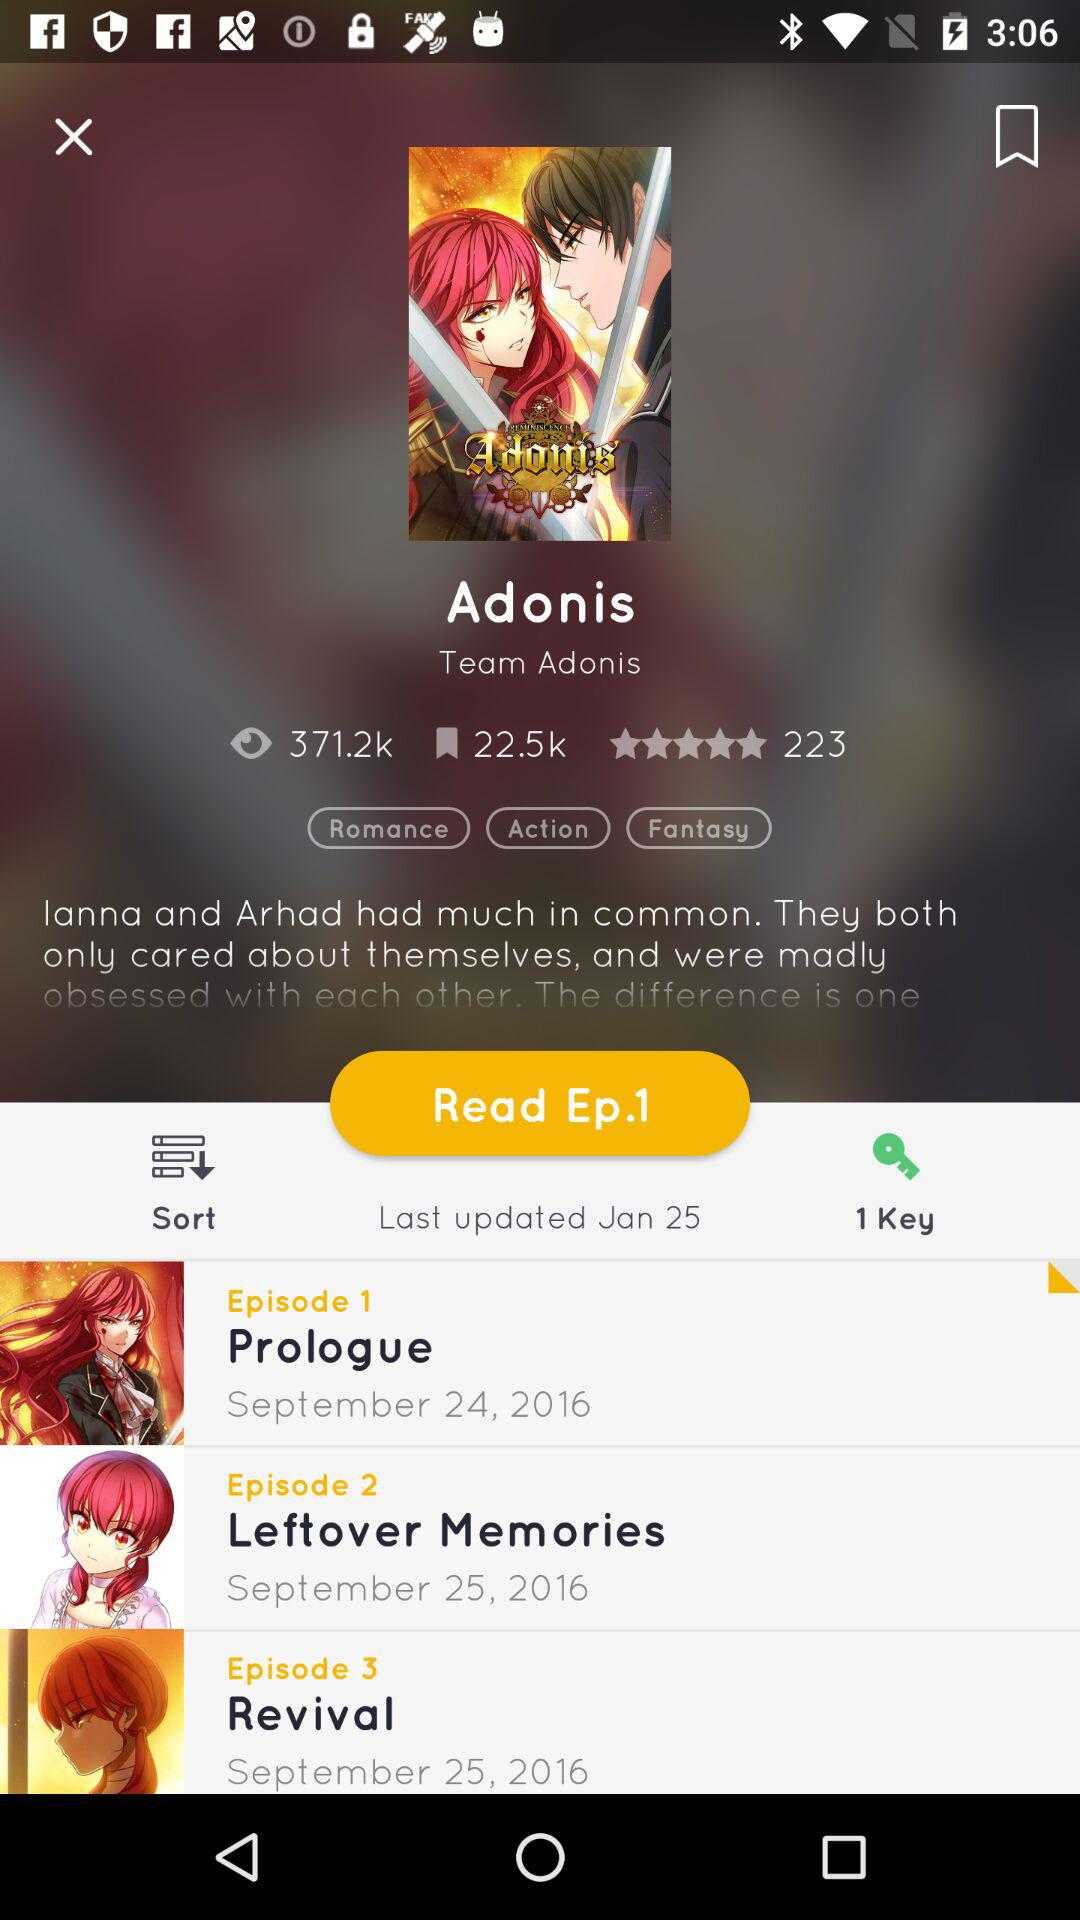What is the name of the drama? The name of the drama is "Adonis". 